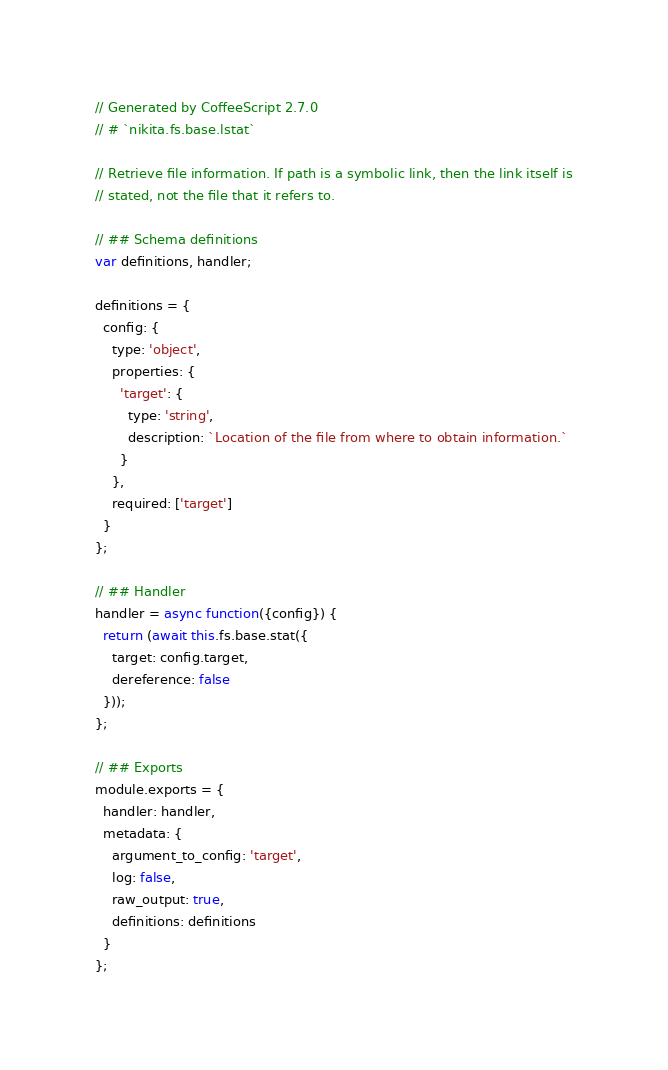<code> <loc_0><loc_0><loc_500><loc_500><_JavaScript_>// Generated by CoffeeScript 2.7.0
// # `nikita.fs.base.lstat`

// Retrieve file information. If path is a symbolic link, then the link itself is
// stated, not the file that it refers to.

// ## Schema definitions
var definitions, handler;

definitions = {
  config: {
    type: 'object',
    properties: {
      'target': {
        type: 'string',
        description: `Location of the file from where to obtain information.`
      }
    },
    required: ['target']
  }
};

// ## Handler
handler = async function({config}) {
  return (await this.fs.base.stat({
    target: config.target,
    dereference: false
  }));
};

// ## Exports
module.exports = {
  handler: handler,
  metadata: {
    argument_to_config: 'target',
    log: false,
    raw_output: true,
    definitions: definitions
  }
};
</code> 